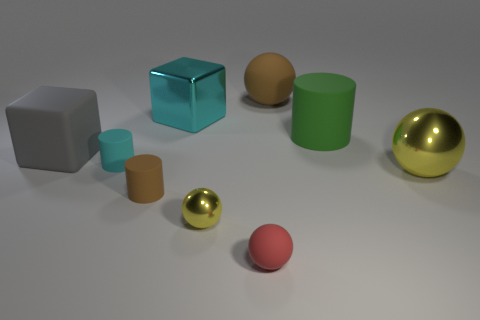Subtract all brown spheres. How many spheres are left? 3 Add 1 large gray matte things. How many objects exist? 10 Subtract 0 blue spheres. How many objects are left? 9 Subtract all cylinders. How many objects are left? 6 Subtract all big blue metallic things. Subtract all large brown matte things. How many objects are left? 8 Add 9 big brown rubber spheres. How many big brown rubber spheres are left? 10 Add 8 large metal things. How many large metal things exist? 10 